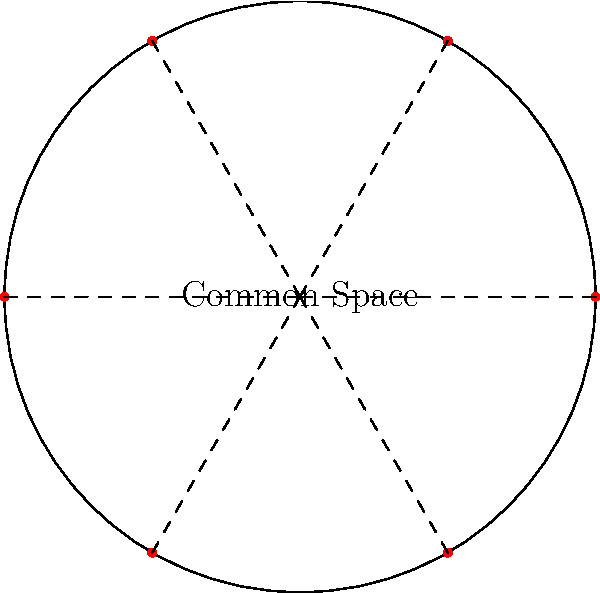A circular common space in a community-owned property has a radius of 15 meters and 6 equally spaced entry points along its perimeter. If the community decides to install a decorative border along the entire perimeter except at the entry points, and each entry point spans an arc length of 2 meters, what length of decorative border material (in meters) is needed? To solve this problem, we need to follow these steps:

1. Calculate the total circumference of the circular common space:
   $C = 2\pi r = 2\pi \cdot 15 = 30\pi$ meters

2. Calculate the total length of all entry points:
   Number of entry points = 6
   Length of each entry point = 2 meters
   Total length of entry points $= 6 \cdot 2 = 12$ meters

3. Subtract the total length of entry points from the circumference:
   Length of decorative border $= 30\pi - 12$ meters

4. Simplify the expression:
   $30\pi - 12 \approx 82.27$ meters

Therefore, the community needs approximately 82.27 meters of decorative border material.
Answer: $30\pi - 12$ meters 